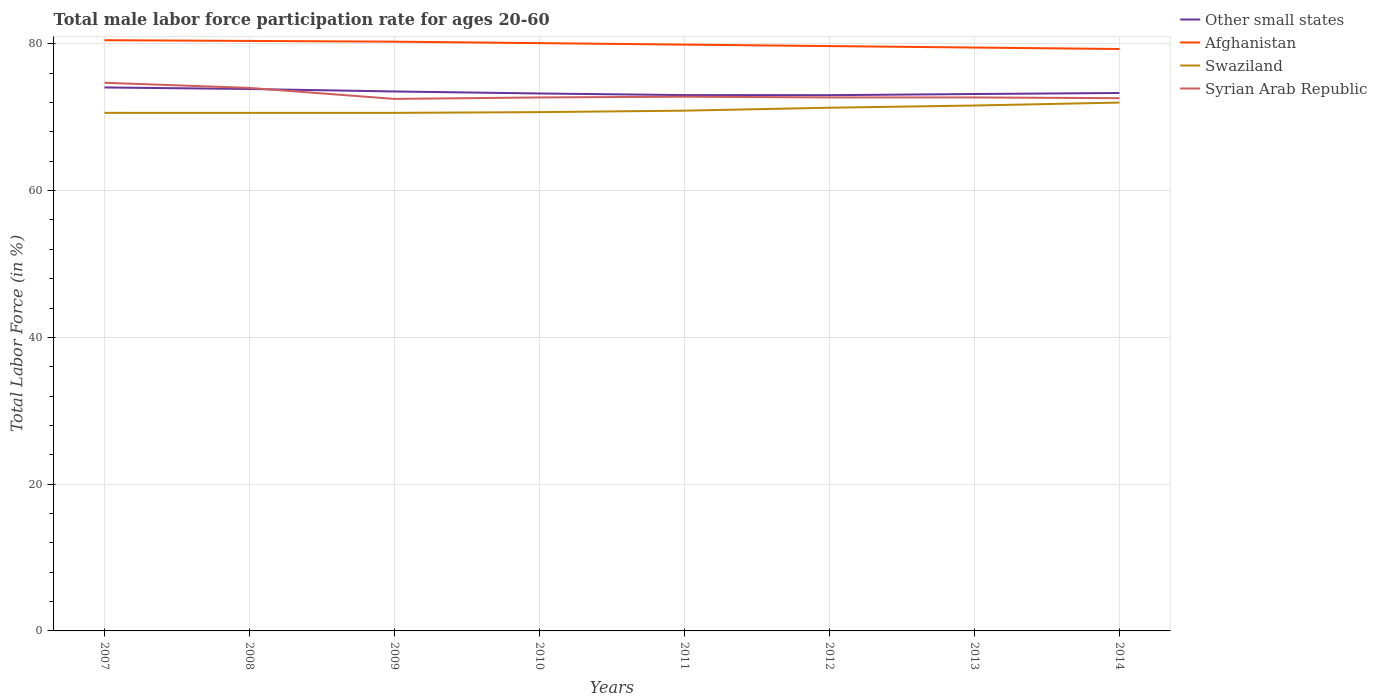How many different coloured lines are there?
Give a very brief answer. 4. Across all years, what is the maximum male labor force participation rate in Other small states?
Your answer should be very brief. 73.01. What is the total male labor force participation rate in Swaziland in the graph?
Offer a terse response. -0.3. What is the difference between the highest and the second highest male labor force participation rate in Swaziland?
Keep it short and to the point. 1.4. What is the difference between the highest and the lowest male labor force participation rate in Afghanistan?
Keep it short and to the point. 4. Is the male labor force participation rate in Other small states strictly greater than the male labor force participation rate in Afghanistan over the years?
Offer a terse response. Yes. How many lines are there?
Provide a succinct answer. 4. What is the difference between two consecutive major ticks on the Y-axis?
Your response must be concise. 20. Does the graph contain any zero values?
Keep it short and to the point. No. Does the graph contain grids?
Offer a terse response. Yes. Where does the legend appear in the graph?
Make the answer very short. Top right. How many legend labels are there?
Your answer should be very brief. 4. What is the title of the graph?
Your answer should be very brief. Total male labor force participation rate for ages 20-60. What is the label or title of the Y-axis?
Your response must be concise. Total Labor Force (in %). What is the Total Labor Force (in %) of Other small states in 2007?
Provide a succinct answer. 74.06. What is the Total Labor Force (in %) of Afghanistan in 2007?
Your answer should be compact. 80.5. What is the Total Labor Force (in %) in Swaziland in 2007?
Offer a terse response. 70.6. What is the Total Labor Force (in %) of Syrian Arab Republic in 2007?
Give a very brief answer. 74.7. What is the Total Labor Force (in %) in Other small states in 2008?
Your response must be concise. 73.85. What is the Total Labor Force (in %) in Afghanistan in 2008?
Offer a terse response. 80.4. What is the Total Labor Force (in %) of Swaziland in 2008?
Your answer should be compact. 70.6. What is the Total Labor Force (in %) in Syrian Arab Republic in 2008?
Your answer should be very brief. 74. What is the Total Labor Force (in %) in Other small states in 2009?
Give a very brief answer. 73.51. What is the Total Labor Force (in %) in Afghanistan in 2009?
Your answer should be compact. 80.3. What is the Total Labor Force (in %) of Swaziland in 2009?
Your answer should be compact. 70.6. What is the Total Labor Force (in %) in Syrian Arab Republic in 2009?
Provide a short and direct response. 72.5. What is the Total Labor Force (in %) in Other small states in 2010?
Your answer should be very brief. 73.24. What is the Total Labor Force (in %) of Afghanistan in 2010?
Provide a succinct answer. 80.1. What is the Total Labor Force (in %) of Swaziland in 2010?
Provide a short and direct response. 70.7. What is the Total Labor Force (in %) in Syrian Arab Republic in 2010?
Your answer should be very brief. 72.7. What is the Total Labor Force (in %) in Other small states in 2011?
Provide a short and direct response. 73.02. What is the Total Labor Force (in %) of Afghanistan in 2011?
Offer a terse response. 79.9. What is the Total Labor Force (in %) in Swaziland in 2011?
Keep it short and to the point. 70.9. What is the Total Labor Force (in %) in Syrian Arab Republic in 2011?
Provide a short and direct response. 72.8. What is the Total Labor Force (in %) of Other small states in 2012?
Ensure brevity in your answer.  73.01. What is the Total Labor Force (in %) in Afghanistan in 2012?
Keep it short and to the point. 79.7. What is the Total Labor Force (in %) of Swaziland in 2012?
Your response must be concise. 71.3. What is the Total Labor Force (in %) of Syrian Arab Republic in 2012?
Offer a terse response. 72.7. What is the Total Labor Force (in %) of Other small states in 2013?
Offer a terse response. 73.17. What is the Total Labor Force (in %) in Afghanistan in 2013?
Provide a succinct answer. 79.5. What is the Total Labor Force (in %) of Swaziland in 2013?
Provide a short and direct response. 71.6. What is the Total Labor Force (in %) in Syrian Arab Republic in 2013?
Your answer should be very brief. 72.7. What is the Total Labor Force (in %) of Other small states in 2014?
Your response must be concise. 73.31. What is the Total Labor Force (in %) in Afghanistan in 2014?
Ensure brevity in your answer.  79.3. What is the Total Labor Force (in %) of Swaziland in 2014?
Keep it short and to the point. 72. What is the Total Labor Force (in %) of Syrian Arab Republic in 2014?
Offer a very short reply. 72.6. Across all years, what is the maximum Total Labor Force (in %) in Other small states?
Keep it short and to the point. 74.06. Across all years, what is the maximum Total Labor Force (in %) in Afghanistan?
Provide a succinct answer. 80.5. Across all years, what is the maximum Total Labor Force (in %) in Swaziland?
Your answer should be compact. 72. Across all years, what is the maximum Total Labor Force (in %) of Syrian Arab Republic?
Ensure brevity in your answer.  74.7. Across all years, what is the minimum Total Labor Force (in %) in Other small states?
Offer a very short reply. 73.01. Across all years, what is the minimum Total Labor Force (in %) of Afghanistan?
Make the answer very short. 79.3. Across all years, what is the minimum Total Labor Force (in %) of Swaziland?
Your answer should be compact. 70.6. Across all years, what is the minimum Total Labor Force (in %) in Syrian Arab Republic?
Give a very brief answer. 72.5. What is the total Total Labor Force (in %) in Other small states in the graph?
Provide a short and direct response. 587.17. What is the total Total Labor Force (in %) in Afghanistan in the graph?
Your response must be concise. 639.7. What is the total Total Labor Force (in %) of Swaziland in the graph?
Provide a succinct answer. 568.3. What is the total Total Labor Force (in %) in Syrian Arab Republic in the graph?
Offer a very short reply. 584.7. What is the difference between the Total Labor Force (in %) in Other small states in 2007 and that in 2008?
Make the answer very short. 0.21. What is the difference between the Total Labor Force (in %) of Syrian Arab Republic in 2007 and that in 2008?
Your answer should be compact. 0.7. What is the difference between the Total Labor Force (in %) of Other small states in 2007 and that in 2009?
Your answer should be compact. 0.55. What is the difference between the Total Labor Force (in %) of Syrian Arab Republic in 2007 and that in 2009?
Offer a terse response. 2.2. What is the difference between the Total Labor Force (in %) of Other small states in 2007 and that in 2010?
Ensure brevity in your answer.  0.82. What is the difference between the Total Labor Force (in %) of Swaziland in 2007 and that in 2010?
Keep it short and to the point. -0.1. What is the difference between the Total Labor Force (in %) of Syrian Arab Republic in 2007 and that in 2010?
Offer a very short reply. 2. What is the difference between the Total Labor Force (in %) in Other small states in 2007 and that in 2011?
Your answer should be very brief. 1.04. What is the difference between the Total Labor Force (in %) in Swaziland in 2007 and that in 2011?
Your answer should be very brief. -0.3. What is the difference between the Total Labor Force (in %) in Other small states in 2007 and that in 2012?
Your answer should be very brief. 1.05. What is the difference between the Total Labor Force (in %) of Afghanistan in 2007 and that in 2012?
Provide a succinct answer. 0.8. What is the difference between the Total Labor Force (in %) of Other small states in 2007 and that in 2013?
Make the answer very short. 0.89. What is the difference between the Total Labor Force (in %) in Swaziland in 2007 and that in 2013?
Your response must be concise. -1. What is the difference between the Total Labor Force (in %) in Syrian Arab Republic in 2007 and that in 2013?
Offer a terse response. 2. What is the difference between the Total Labor Force (in %) in Other small states in 2007 and that in 2014?
Offer a very short reply. 0.75. What is the difference between the Total Labor Force (in %) in Afghanistan in 2007 and that in 2014?
Keep it short and to the point. 1.2. What is the difference between the Total Labor Force (in %) of Swaziland in 2007 and that in 2014?
Offer a very short reply. -1.4. What is the difference between the Total Labor Force (in %) of Syrian Arab Republic in 2007 and that in 2014?
Provide a short and direct response. 2.1. What is the difference between the Total Labor Force (in %) in Other small states in 2008 and that in 2009?
Keep it short and to the point. 0.34. What is the difference between the Total Labor Force (in %) of Afghanistan in 2008 and that in 2009?
Keep it short and to the point. 0.1. What is the difference between the Total Labor Force (in %) in Syrian Arab Republic in 2008 and that in 2009?
Offer a terse response. 1.5. What is the difference between the Total Labor Force (in %) of Other small states in 2008 and that in 2010?
Ensure brevity in your answer.  0.61. What is the difference between the Total Labor Force (in %) of Afghanistan in 2008 and that in 2010?
Provide a short and direct response. 0.3. What is the difference between the Total Labor Force (in %) in Swaziland in 2008 and that in 2010?
Offer a terse response. -0.1. What is the difference between the Total Labor Force (in %) in Syrian Arab Republic in 2008 and that in 2010?
Offer a terse response. 1.3. What is the difference between the Total Labor Force (in %) of Other small states in 2008 and that in 2011?
Offer a very short reply. 0.83. What is the difference between the Total Labor Force (in %) of Afghanistan in 2008 and that in 2011?
Your answer should be very brief. 0.5. What is the difference between the Total Labor Force (in %) in Other small states in 2008 and that in 2012?
Your response must be concise. 0.84. What is the difference between the Total Labor Force (in %) in Other small states in 2008 and that in 2013?
Make the answer very short. 0.68. What is the difference between the Total Labor Force (in %) in Afghanistan in 2008 and that in 2013?
Ensure brevity in your answer.  0.9. What is the difference between the Total Labor Force (in %) in Syrian Arab Republic in 2008 and that in 2013?
Your answer should be very brief. 1.3. What is the difference between the Total Labor Force (in %) in Other small states in 2008 and that in 2014?
Your answer should be compact. 0.54. What is the difference between the Total Labor Force (in %) of Syrian Arab Republic in 2008 and that in 2014?
Keep it short and to the point. 1.4. What is the difference between the Total Labor Force (in %) in Other small states in 2009 and that in 2010?
Provide a short and direct response. 0.28. What is the difference between the Total Labor Force (in %) in Swaziland in 2009 and that in 2010?
Your response must be concise. -0.1. What is the difference between the Total Labor Force (in %) in Other small states in 2009 and that in 2011?
Provide a short and direct response. 0.49. What is the difference between the Total Labor Force (in %) in Other small states in 2009 and that in 2012?
Your response must be concise. 0.5. What is the difference between the Total Labor Force (in %) of Afghanistan in 2009 and that in 2012?
Provide a short and direct response. 0.6. What is the difference between the Total Labor Force (in %) of Swaziland in 2009 and that in 2012?
Provide a short and direct response. -0.7. What is the difference between the Total Labor Force (in %) in Other small states in 2009 and that in 2013?
Provide a short and direct response. 0.35. What is the difference between the Total Labor Force (in %) of Afghanistan in 2009 and that in 2013?
Make the answer very short. 0.8. What is the difference between the Total Labor Force (in %) in Syrian Arab Republic in 2009 and that in 2013?
Provide a succinct answer. -0.2. What is the difference between the Total Labor Force (in %) of Other small states in 2009 and that in 2014?
Your answer should be very brief. 0.21. What is the difference between the Total Labor Force (in %) of Syrian Arab Republic in 2009 and that in 2014?
Ensure brevity in your answer.  -0.1. What is the difference between the Total Labor Force (in %) in Other small states in 2010 and that in 2011?
Your response must be concise. 0.22. What is the difference between the Total Labor Force (in %) of Afghanistan in 2010 and that in 2011?
Offer a terse response. 0.2. What is the difference between the Total Labor Force (in %) in Other small states in 2010 and that in 2012?
Give a very brief answer. 0.23. What is the difference between the Total Labor Force (in %) of Afghanistan in 2010 and that in 2012?
Ensure brevity in your answer.  0.4. What is the difference between the Total Labor Force (in %) in Swaziland in 2010 and that in 2012?
Provide a short and direct response. -0.6. What is the difference between the Total Labor Force (in %) of Other small states in 2010 and that in 2013?
Make the answer very short. 0.07. What is the difference between the Total Labor Force (in %) in Afghanistan in 2010 and that in 2013?
Offer a very short reply. 0.6. What is the difference between the Total Labor Force (in %) in Other small states in 2010 and that in 2014?
Keep it short and to the point. -0.07. What is the difference between the Total Labor Force (in %) of Syrian Arab Republic in 2010 and that in 2014?
Provide a short and direct response. 0.1. What is the difference between the Total Labor Force (in %) of Other small states in 2011 and that in 2012?
Give a very brief answer. 0.01. What is the difference between the Total Labor Force (in %) in Syrian Arab Republic in 2011 and that in 2012?
Offer a terse response. 0.1. What is the difference between the Total Labor Force (in %) in Other small states in 2011 and that in 2013?
Provide a succinct answer. -0.15. What is the difference between the Total Labor Force (in %) of Afghanistan in 2011 and that in 2013?
Keep it short and to the point. 0.4. What is the difference between the Total Labor Force (in %) of Other small states in 2011 and that in 2014?
Provide a succinct answer. -0.29. What is the difference between the Total Labor Force (in %) of Swaziland in 2011 and that in 2014?
Your answer should be compact. -1.1. What is the difference between the Total Labor Force (in %) of Syrian Arab Republic in 2011 and that in 2014?
Ensure brevity in your answer.  0.2. What is the difference between the Total Labor Force (in %) of Other small states in 2012 and that in 2013?
Your response must be concise. -0.16. What is the difference between the Total Labor Force (in %) of Syrian Arab Republic in 2012 and that in 2013?
Ensure brevity in your answer.  0. What is the difference between the Total Labor Force (in %) of Other small states in 2012 and that in 2014?
Keep it short and to the point. -0.3. What is the difference between the Total Labor Force (in %) in Afghanistan in 2012 and that in 2014?
Provide a succinct answer. 0.4. What is the difference between the Total Labor Force (in %) of Syrian Arab Republic in 2012 and that in 2014?
Your answer should be compact. 0.1. What is the difference between the Total Labor Force (in %) of Other small states in 2013 and that in 2014?
Provide a succinct answer. -0.14. What is the difference between the Total Labor Force (in %) of Afghanistan in 2013 and that in 2014?
Ensure brevity in your answer.  0.2. What is the difference between the Total Labor Force (in %) of Other small states in 2007 and the Total Labor Force (in %) of Afghanistan in 2008?
Your answer should be very brief. -6.34. What is the difference between the Total Labor Force (in %) in Other small states in 2007 and the Total Labor Force (in %) in Swaziland in 2008?
Provide a succinct answer. 3.46. What is the difference between the Total Labor Force (in %) of Other small states in 2007 and the Total Labor Force (in %) of Syrian Arab Republic in 2008?
Provide a short and direct response. 0.06. What is the difference between the Total Labor Force (in %) in Other small states in 2007 and the Total Labor Force (in %) in Afghanistan in 2009?
Give a very brief answer. -6.24. What is the difference between the Total Labor Force (in %) of Other small states in 2007 and the Total Labor Force (in %) of Swaziland in 2009?
Ensure brevity in your answer.  3.46. What is the difference between the Total Labor Force (in %) of Other small states in 2007 and the Total Labor Force (in %) of Syrian Arab Republic in 2009?
Ensure brevity in your answer.  1.56. What is the difference between the Total Labor Force (in %) in Other small states in 2007 and the Total Labor Force (in %) in Afghanistan in 2010?
Your answer should be compact. -6.04. What is the difference between the Total Labor Force (in %) in Other small states in 2007 and the Total Labor Force (in %) in Swaziland in 2010?
Provide a succinct answer. 3.36. What is the difference between the Total Labor Force (in %) in Other small states in 2007 and the Total Labor Force (in %) in Syrian Arab Republic in 2010?
Your answer should be very brief. 1.36. What is the difference between the Total Labor Force (in %) of Swaziland in 2007 and the Total Labor Force (in %) of Syrian Arab Republic in 2010?
Offer a very short reply. -2.1. What is the difference between the Total Labor Force (in %) of Other small states in 2007 and the Total Labor Force (in %) of Afghanistan in 2011?
Make the answer very short. -5.84. What is the difference between the Total Labor Force (in %) of Other small states in 2007 and the Total Labor Force (in %) of Swaziland in 2011?
Offer a terse response. 3.16. What is the difference between the Total Labor Force (in %) of Other small states in 2007 and the Total Labor Force (in %) of Syrian Arab Republic in 2011?
Provide a short and direct response. 1.26. What is the difference between the Total Labor Force (in %) of Other small states in 2007 and the Total Labor Force (in %) of Afghanistan in 2012?
Your answer should be compact. -5.64. What is the difference between the Total Labor Force (in %) in Other small states in 2007 and the Total Labor Force (in %) in Swaziland in 2012?
Your answer should be compact. 2.76. What is the difference between the Total Labor Force (in %) of Other small states in 2007 and the Total Labor Force (in %) of Syrian Arab Republic in 2012?
Provide a short and direct response. 1.36. What is the difference between the Total Labor Force (in %) in Afghanistan in 2007 and the Total Labor Force (in %) in Swaziland in 2012?
Give a very brief answer. 9.2. What is the difference between the Total Labor Force (in %) of Other small states in 2007 and the Total Labor Force (in %) of Afghanistan in 2013?
Offer a terse response. -5.44. What is the difference between the Total Labor Force (in %) in Other small states in 2007 and the Total Labor Force (in %) in Swaziland in 2013?
Ensure brevity in your answer.  2.46. What is the difference between the Total Labor Force (in %) of Other small states in 2007 and the Total Labor Force (in %) of Syrian Arab Republic in 2013?
Ensure brevity in your answer.  1.36. What is the difference between the Total Labor Force (in %) in Afghanistan in 2007 and the Total Labor Force (in %) in Swaziland in 2013?
Offer a very short reply. 8.9. What is the difference between the Total Labor Force (in %) in Afghanistan in 2007 and the Total Labor Force (in %) in Syrian Arab Republic in 2013?
Your answer should be very brief. 7.8. What is the difference between the Total Labor Force (in %) in Other small states in 2007 and the Total Labor Force (in %) in Afghanistan in 2014?
Keep it short and to the point. -5.24. What is the difference between the Total Labor Force (in %) in Other small states in 2007 and the Total Labor Force (in %) in Swaziland in 2014?
Provide a short and direct response. 2.06. What is the difference between the Total Labor Force (in %) of Other small states in 2007 and the Total Labor Force (in %) of Syrian Arab Republic in 2014?
Offer a very short reply. 1.46. What is the difference between the Total Labor Force (in %) of Swaziland in 2007 and the Total Labor Force (in %) of Syrian Arab Republic in 2014?
Keep it short and to the point. -2. What is the difference between the Total Labor Force (in %) of Other small states in 2008 and the Total Labor Force (in %) of Afghanistan in 2009?
Offer a terse response. -6.45. What is the difference between the Total Labor Force (in %) in Other small states in 2008 and the Total Labor Force (in %) in Swaziland in 2009?
Offer a very short reply. 3.25. What is the difference between the Total Labor Force (in %) of Other small states in 2008 and the Total Labor Force (in %) of Syrian Arab Republic in 2009?
Provide a short and direct response. 1.35. What is the difference between the Total Labor Force (in %) of Afghanistan in 2008 and the Total Labor Force (in %) of Syrian Arab Republic in 2009?
Give a very brief answer. 7.9. What is the difference between the Total Labor Force (in %) of Other small states in 2008 and the Total Labor Force (in %) of Afghanistan in 2010?
Provide a succinct answer. -6.25. What is the difference between the Total Labor Force (in %) of Other small states in 2008 and the Total Labor Force (in %) of Swaziland in 2010?
Provide a succinct answer. 3.15. What is the difference between the Total Labor Force (in %) in Other small states in 2008 and the Total Labor Force (in %) in Syrian Arab Republic in 2010?
Your response must be concise. 1.15. What is the difference between the Total Labor Force (in %) of Other small states in 2008 and the Total Labor Force (in %) of Afghanistan in 2011?
Give a very brief answer. -6.05. What is the difference between the Total Labor Force (in %) in Other small states in 2008 and the Total Labor Force (in %) in Swaziland in 2011?
Ensure brevity in your answer.  2.95. What is the difference between the Total Labor Force (in %) of Other small states in 2008 and the Total Labor Force (in %) of Syrian Arab Republic in 2011?
Provide a short and direct response. 1.05. What is the difference between the Total Labor Force (in %) in Other small states in 2008 and the Total Labor Force (in %) in Afghanistan in 2012?
Ensure brevity in your answer.  -5.85. What is the difference between the Total Labor Force (in %) in Other small states in 2008 and the Total Labor Force (in %) in Swaziland in 2012?
Give a very brief answer. 2.55. What is the difference between the Total Labor Force (in %) in Other small states in 2008 and the Total Labor Force (in %) in Syrian Arab Republic in 2012?
Offer a very short reply. 1.15. What is the difference between the Total Labor Force (in %) of Afghanistan in 2008 and the Total Labor Force (in %) of Syrian Arab Republic in 2012?
Keep it short and to the point. 7.7. What is the difference between the Total Labor Force (in %) of Swaziland in 2008 and the Total Labor Force (in %) of Syrian Arab Republic in 2012?
Offer a terse response. -2.1. What is the difference between the Total Labor Force (in %) of Other small states in 2008 and the Total Labor Force (in %) of Afghanistan in 2013?
Your response must be concise. -5.65. What is the difference between the Total Labor Force (in %) of Other small states in 2008 and the Total Labor Force (in %) of Swaziland in 2013?
Offer a terse response. 2.25. What is the difference between the Total Labor Force (in %) in Other small states in 2008 and the Total Labor Force (in %) in Syrian Arab Republic in 2013?
Ensure brevity in your answer.  1.15. What is the difference between the Total Labor Force (in %) of Afghanistan in 2008 and the Total Labor Force (in %) of Swaziland in 2013?
Ensure brevity in your answer.  8.8. What is the difference between the Total Labor Force (in %) in Swaziland in 2008 and the Total Labor Force (in %) in Syrian Arab Republic in 2013?
Keep it short and to the point. -2.1. What is the difference between the Total Labor Force (in %) of Other small states in 2008 and the Total Labor Force (in %) of Afghanistan in 2014?
Make the answer very short. -5.45. What is the difference between the Total Labor Force (in %) in Other small states in 2008 and the Total Labor Force (in %) in Swaziland in 2014?
Offer a very short reply. 1.85. What is the difference between the Total Labor Force (in %) of Other small states in 2008 and the Total Labor Force (in %) of Syrian Arab Republic in 2014?
Make the answer very short. 1.25. What is the difference between the Total Labor Force (in %) in Afghanistan in 2008 and the Total Labor Force (in %) in Syrian Arab Republic in 2014?
Provide a short and direct response. 7.8. What is the difference between the Total Labor Force (in %) of Swaziland in 2008 and the Total Labor Force (in %) of Syrian Arab Republic in 2014?
Offer a very short reply. -2. What is the difference between the Total Labor Force (in %) of Other small states in 2009 and the Total Labor Force (in %) of Afghanistan in 2010?
Make the answer very short. -6.59. What is the difference between the Total Labor Force (in %) in Other small states in 2009 and the Total Labor Force (in %) in Swaziland in 2010?
Give a very brief answer. 2.81. What is the difference between the Total Labor Force (in %) of Other small states in 2009 and the Total Labor Force (in %) of Syrian Arab Republic in 2010?
Ensure brevity in your answer.  0.81. What is the difference between the Total Labor Force (in %) in Afghanistan in 2009 and the Total Labor Force (in %) in Swaziland in 2010?
Ensure brevity in your answer.  9.6. What is the difference between the Total Labor Force (in %) in Afghanistan in 2009 and the Total Labor Force (in %) in Syrian Arab Republic in 2010?
Your response must be concise. 7.6. What is the difference between the Total Labor Force (in %) in Swaziland in 2009 and the Total Labor Force (in %) in Syrian Arab Republic in 2010?
Offer a very short reply. -2.1. What is the difference between the Total Labor Force (in %) in Other small states in 2009 and the Total Labor Force (in %) in Afghanistan in 2011?
Provide a succinct answer. -6.39. What is the difference between the Total Labor Force (in %) in Other small states in 2009 and the Total Labor Force (in %) in Swaziland in 2011?
Provide a short and direct response. 2.61. What is the difference between the Total Labor Force (in %) in Other small states in 2009 and the Total Labor Force (in %) in Syrian Arab Republic in 2011?
Your answer should be compact. 0.71. What is the difference between the Total Labor Force (in %) in Afghanistan in 2009 and the Total Labor Force (in %) in Swaziland in 2011?
Make the answer very short. 9.4. What is the difference between the Total Labor Force (in %) of Swaziland in 2009 and the Total Labor Force (in %) of Syrian Arab Republic in 2011?
Give a very brief answer. -2.2. What is the difference between the Total Labor Force (in %) in Other small states in 2009 and the Total Labor Force (in %) in Afghanistan in 2012?
Provide a short and direct response. -6.19. What is the difference between the Total Labor Force (in %) in Other small states in 2009 and the Total Labor Force (in %) in Swaziland in 2012?
Make the answer very short. 2.21. What is the difference between the Total Labor Force (in %) in Other small states in 2009 and the Total Labor Force (in %) in Syrian Arab Republic in 2012?
Ensure brevity in your answer.  0.81. What is the difference between the Total Labor Force (in %) of Afghanistan in 2009 and the Total Labor Force (in %) of Swaziland in 2012?
Offer a terse response. 9. What is the difference between the Total Labor Force (in %) of Afghanistan in 2009 and the Total Labor Force (in %) of Syrian Arab Republic in 2012?
Your answer should be compact. 7.6. What is the difference between the Total Labor Force (in %) in Swaziland in 2009 and the Total Labor Force (in %) in Syrian Arab Republic in 2012?
Provide a short and direct response. -2.1. What is the difference between the Total Labor Force (in %) of Other small states in 2009 and the Total Labor Force (in %) of Afghanistan in 2013?
Your answer should be very brief. -5.99. What is the difference between the Total Labor Force (in %) in Other small states in 2009 and the Total Labor Force (in %) in Swaziland in 2013?
Your answer should be very brief. 1.91. What is the difference between the Total Labor Force (in %) of Other small states in 2009 and the Total Labor Force (in %) of Syrian Arab Republic in 2013?
Make the answer very short. 0.81. What is the difference between the Total Labor Force (in %) of Swaziland in 2009 and the Total Labor Force (in %) of Syrian Arab Republic in 2013?
Offer a terse response. -2.1. What is the difference between the Total Labor Force (in %) in Other small states in 2009 and the Total Labor Force (in %) in Afghanistan in 2014?
Your response must be concise. -5.79. What is the difference between the Total Labor Force (in %) in Other small states in 2009 and the Total Labor Force (in %) in Swaziland in 2014?
Give a very brief answer. 1.51. What is the difference between the Total Labor Force (in %) in Other small states in 2009 and the Total Labor Force (in %) in Syrian Arab Republic in 2014?
Make the answer very short. 0.91. What is the difference between the Total Labor Force (in %) in Afghanistan in 2009 and the Total Labor Force (in %) in Swaziland in 2014?
Provide a succinct answer. 8.3. What is the difference between the Total Labor Force (in %) of Afghanistan in 2009 and the Total Labor Force (in %) of Syrian Arab Republic in 2014?
Your answer should be compact. 7.7. What is the difference between the Total Labor Force (in %) of Swaziland in 2009 and the Total Labor Force (in %) of Syrian Arab Republic in 2014?
Keep it short and to the point. -2. What is the difference between the Total Labor Force (in %) of Other small states in 2010 and the Total Labor Force (in %) of Afghanistan in 2011?
Keep it short and to the point. -6.66. What is the difference between the Total Labor Force (in %) of Other small states in 2010 and the Total Labor Force (in %) of Swaziland in 2011?
Keep it short and to the point. 2.34. What is the difference between the Total Labor Force (in %) of Other small states in 2010 and the Total Labor Force (in %) of Syrian Arab Republic in 2011?
Your answer should be very brief. 0.44. What is the difference between the Total Labor Force (in %) of Other small states in 2010 and the Total Labor Force (in %) of Afghanistan in 2012?
Your response must be concise. -6.46. What is the difference between the Total Labor Force (in %) of Other small states in 2010 and the Total Labor Force (in %) of Swaziland in 2012?
Give a very brief answer. 1.94. What is the difference between the Total Labor Force (in %) of Other small states in 2010 and the Total Labor Force (in %) of Syrian Arab Republic in 2012?
Make the answer very short. 0.54. What is the difference between the Total Labor Force (in %) in Afghanistan in 2010 and the Total Labor Force (in %) in Syrian Arab Republic in 2012?
Provide a succinct answer. 7.4. What is the difference between the Total Labor Force (in %) in Other small states in 2010 and the Total Labor Force (in %) in Afghanistan in 2013?
Offer a terse response. -6.26. What is the difference between the Total Labor Force (in %) of Other small states in 2010 and the Total Labor Force (in %) of Swaziland in 2013?
Make the answer very short. 1.64. What is the difference between the Total Labor Force (in %) in Other small states in 2010 and the Total Labor Force (in %) in Syrian Arab Republic in 2013?
Make the answer very short. 0.54. What is the difference between the Total Labor Force (in %) of Afghanistan in 2010 and the Total Labor Force (in %) of Syrian Arab Republic in 2013?
Give a very brief answer. 7.4. What is the difference between the Total Labor Force (in %) in Swaziland in 2010 and the Total Labor Force (in %) in Syrian Arab Republic in 2013?
Offer a very short reply. -2. What is the difference between the Total Labor Force (in %) in Other small states in 2010 and the Total Labor Force (in %) in Afghanistan in 2014?
Give a very brief answer. -6.06. What is the difference between the Total Labor Force (in %) of Other small states in 2010 and the Total Labor Force (in %) of Swaziland in 2014?
Provide a short and direct response. 1.24. What is the difference between the Total Labor Force (in %) in Other small states in 2010 and the Total Labor Force (in %) in Syrian Arab Republic in 2014?
Provide a short and direct response. 0.64. What is the difference between the Total Labor Force (in %) of Afghanistan in 2010 and the Total Labor Force (in %) of Swaziland in 2014?
Keep it short and to the point. 8.1. What is the difference between the Total Labor Force (in %) in Afghanistan in 2010 and the Total Labor Force (in %) in Syrian Arab Republic in 2014?
Provide a short and direct response. 7.5. What is the difference between the Total Labor Force (in %) in Other small states in 2011 and the Total Labor Force (in %) in Afghanistan in 2012?
Offer a very short reply. -6.68. What is the difference between the Total Labor Force (in %) of Other small states in 2011 and the Total Labor Force (in %) of Swaziland in 2012?
Ensure brevity in your answer.  1.72. What is the difference between the Total Labor Force (in %) of Other small states in 2011 and the Total Labor Force (in %) of Syrian Arab Republic in 2012?
Make the answer very short. 0.32. What is the difference between the Total Labor Force (in %) in Afghanistan in 2011 and the Total Labor Force (in %) in Swaziland in 2012?
Your answer should be compact. 8.6. What is the difference between the Total Labor Force (in %) of Afghanistan in 2011 and the Total Labor Force (in %) of Syrian Arab Republic in 2012?
Your answer should be compact. 7.2. What is the difference between the Total Labor Force (in %) of Other small states in 2011 and the Total Labor Force (in %) of Afghanistan in 2013?
Offer a very short reply. -6.48. What is the difference between the Total Labor Force (in %) in Other small states in 2011 and the Total Labor Force (in %) in Swaziland in 2013?
Keep it short and to the point. 1.42. What is the difference between the Total Labor Force (in %) of Other small states in 2011 and the Total Labor Force (in %) of Syrian Arab Republic in 2013?
Offer a terse response. 0.32. What is the difference between the Total Labor Force (in %) in Afghanistan in 2011 and the Total Labor Force (in %) in Syrian Arab Republic in 2013?
Your response must be concise. 7.2. What is the difference between the Total Labor Force (in %) in Swaziland in 2011 and the Total Labor Force (in %) in Syrian Arab Republic in 2013?
Keep it short and to the point. -1.8. What is the difference between the Total Labor Force (in %) in Other small states in 2011 and the Total Labor Force (in %) in Afghanistan in 2014?
Provide a succinct answer. -6.28. What is the difference between the Total Labor Force (in %) in Other small states in 2011 and the Total Labor Force (in %) in Swaziland in 2014?
Your answer should be compact. 1.02. What is the difference between the Total Labor Force (in %) of Other small states in 2011 and the Total Labor Force (in %) of Syrian Arab Republic in 2014?
Keep it short and to the point. 0.42. What is the difference between the Total Labor Force (in %) in Swaziland in 2011 and the Total Labor Force (in %) in Syrian Arab Republic in 2014?
Keep it short and to the point. -1.7. What is the difference between the Total Labor Force (in %) of Other small states in 2012 and the Total Labor Force (in %) of Afghanistan in 2013?
Keep it short and to the point. -6.49. What is the difference between the Total Labor Force (in %) of Other small states in 2012 and the Total Labor Force (in %) of Swaziland in 2013?
Provide a succinct answer. 1.41. What is the difference between the Total Labor Force (in %) in Other small states in 2012 and the Total Labor Force (in %) in Syrian Arab Republic in 2013?
Ensure brevity in your answer.  0.31. What is the difference between the Total Labor Force (in %) of Afghanistan in 2012 and the Total Labor Force (in %) of Syrian Arab Republic in 2013?
Ensure brevity in your answer.  7. What is the difference between the Total Labor Force (in %) in Swaziland in 2012 and the Total Labor Force (in %) in Syrian Arab Republic in 2013?
Offer a very short reply. -1.4. What is the difference between the Total Labor Force (in %) of Other small states in 2012 and the Total Labor Force (in %) of Afghanistan in 2014?
Offer a very short reply. -6.29. What is the difference between the Total Labor Force (in %) of Other small states in 2012 and the Total Labor Force (in %) of Swaziland in 2014?
Your answer should be compact. 1.01. What is the difference between the Total Labor Force (in %) of Other small states in 2012 and the Total Labor Force (in %) of Syrian Arab Republic in 2014?
Make the answer very short. 0.41. What is the difference between the Total Labor Force (in %) of Afghanistan in 2012 and the Total Labor Force (in %) of Syrian Arab Republic in 2014?
Offer a very short reply. 7.1. What is the difference between the Total Labor Force (in %) in Other small states in 2013 and the Total Labor Force (in %) in Afghanistan in 2014?
Provide a short and direct response. -6.13. What is the difference between the Total Labor Force (in %) in Other small states in 2013 and the Total Labor Force (in %) in Swaziland in 2014?
Provide a short and direct response. 1.17. What is the difference between the Total Labor Force (in %) in Other small states in 2013 and the Total Labor Force (in %) in Syrian Arab Republic in 2014?
Ensure brevity in your answer.  0.57. What is the difference between the Total Labor Force (in %) of Afghanistan in 2013 and the Total Labor Force (in %) of Swaziland in 2014?
Your answer should be very brief. 7.5. What is the difference between the Total Labor Force (in %) in Afghanistan in 2013 and the Total Labor Force (in %) in Syrian Arab Republic in 2014?
Provide a succinct answer. 6.9. What is the difference between the Total Labor Force (in %) of Swaziland in 2013 and the Total Labor Force (in %) of Syrian Arab Republic in 2014?
Your answer should be very brief. -1. What is the average Total Labor Force (in %) in Other small states per year?
Ensure brevity in your answer.  73.4. What is the average Total Labor Force (in %) of Afghanistan per year?
Keep it short and to the point. 79.96. What is the average Total Labor Force (in %) of Swaziland per year?
Your answer should be very brief. 71.04. What is the average Total Labor Force (in %) in Syrian Arab Republic per year?
Offer a very short reply. 73.09. In the year 2007, what is the difference between the Total Labor Force (in %) of Other small states and Total Labor Force (in %) of Afghanistan?
Give a very brief answer. -6.44. In the year 2007, what is the difference between the Total Labor Force (in %) in Other small states and Total Labor Force (in %) in Swaziland?
Ensure brevity in your answer.  3.46. In the year 2007, what is the difference between the Total Labor Force (in %) of Other small states and Total Labor Force (in %) of Syrian Arab Republic?
Provide a short and direct response. -0.64. In the year 2007, what is the difference between the Total Labor Force (in %) in Afghanistan and Total Labor Force (in %) in Swaziland?
Give a very brief answer. 9.9. In the year 2007, what is the difference between the Total Labor Force (in %) in Afghanistan and Total Labor Force (in %) in Syrian Arab Republic?
Offer a very short reply. 5.8. In the year 2008, what is the difference between the Total Labor Force (in %) in Other small states and Total Labor Force (in %) in Afghanistan?
Your answer should be compact. -6.55. In the year 2008, what is the difference between the Total Labor Force (in %) of Other small states and Total Labor Force (in %) of Swaziland?
Offer a terse response. 3.25. In the year 2008, what is the difference between the Total Labor Force (in %) of Other small states and Total Labor Force (in %) of Syrian Arab Republic?
Offer a terse response. -0.15. In the year 2009, what is the difference between the Total Labor Force (in %) in Other small states and Total Labor Force (in %) in Afghanistan?
Make the answer very short. -6.79. In the year 2009, what is the difference between the Total Labor Force (in %) of Other small states and Total Labor Force (in %) of Swaziland?
Provide a short and direct response. 2.91. In the year 2009, what is the difference between the Total Labor Force (in %) in Other small states and Total Labor Force (in %) in Syrian Arab Republic?
Keep it short and to the point. 1.01. In the year 2009, what is the difference between the Total Labor Force (in %) in Afghanistan and Total Labor Force (in %) in Swaziland?
Give a very brief answer. 9.7. In the year 2009, what is the difference between the Total Labor Force (in %) of Afghanistan and Total Labor Force (in %) of Syrian Arab Republic?
Offer a very short reply. 7.8. In the year 2010, what is the difference between the Total Labor Force (in %) of Other small states and Total Labor Force (in %) of Afghanistan?
Offer a terse response. -6.86. In the year 2010, what is the difference between the Total Labor Force (in %) of Other small states and Total Labor Force (in %) of Swaziland?
Offer a terse response. 2.54. In the year 2010, what is the difference between the Total Labor Force (in %) of Other small states and Total Labor Force (in %) of Syrian Arab Republic?
Your response must be concise. 0.54. In the year 2010, what is the difference between the Total Labor Force (in %) in Afghanistan and Total Labor Force (in %) in Syrian Arab Republic?
Your response must be concise. 7.4. In the year 2010, what is the difference between the Total Labor Force (in %) in Swaziland and Total Labor Force (in %) in Syrian Arab Republic?
Ensure brevity in your answer.  -2. In the year 2011, what is the difference between the Total Labor Force (in %) of Other small states and Total Labor Force (in %) of Afghanistan?
Offer a terse response. -6.88. In the year 2011, what is the difference between the Total Labor Force (in %) of Other small states and Total Labor Force (in %) of Swaziland?
Your response must be concise. 2.12. In the year 2011, what is the difference between the Total Labor Force (in %) of Other small states and Total Labor Force (in %) of Syrian Arab Republic?
Provide a succinct answer. 0.22. In the year 2011, what is the difference between the Total Labor Force (in %) in Afghanistan and Total Labor Force (in %) in Syrian Arab Republic?
Your response must be concise. 7.1. In the year 2012, what is the difference between the Total Labor Force (in %) of Other small states and Total Labor Force (in %) of Afghanistan?
Ensure brevity in your answer.  -6.69. In the year 2012, what is the difference between the Total Labor Force (in %) in Other small states and Total Labor Force (in %) in Swaziland?
Provide a short and direct response. 1.71. In the year 2012, what is the difference between the Total Labor Force (in %) in Other small states and Total Labor Force (in %) in Syrian Arab Republic?
Keep it short and to the point. 0.31. In the year 2012, what is the difference between the Total Labor Force (in %) of Afghanistan and Total Labor Force (in %) of Syrian Arab Republic?
Your response must be concise. 7. In the year 2012, what is the difference between the Total Labor Force (in %) of Swaziland and Total Labor Force (in %) of Syrian Arab Republic?
Your answer should be compact. -1.4. In the year 2013, what is the difference between the Total Labor Force (in %) of Other small states and Total Labor Force (in %) of Afghanistan?
Provide a succinct answer. -6.33. In the year 2013, what is the difference between the Total Labor Force (in %) of Other small states and Total Labor Force (in %) of Swaziland?
Give a very brief answer. 1.57. In the year 2013, what is the difference between the Total Labor Force (in %) in Other small states and Total Labor Force (in %) in Syrian Arab Republic?
Offer a terse response. 0.47. In the year 2013, what is the difference between the Total Labor Force (in %) in Afghanistan and Total Labor Force (in %) in Swaziland?
Ensure brevity in your answer.  7.9. In the year 2013, what is the difference between the Total Labor Force (in %) of Swaziland and Total Labor Force (in %) of Syrian Arab Republic?
Offer a very short reply. -1.1. In the year 2014, what is the difference between the Total Labor Force (in %) of Other small states and Total Labor Force (in %) of Afghanistan?
Ensure brevity in your answer.  -5.99. In the year 2014, what is the difference between the Total Labor Force (in %) of Other small states and Total Labor Force (in %) of Swaziland?
Make the answer very short. 1.31. In the year 2014, what is the difference between the Total Labor Force (in %) in Other small states and Total Labor Force (in %) in Syrian Arab Republic?
Offer a terse response. 0.71. What is the ratio of the Total Labor Force (in %) of Afghanistan in 2007 to that in 2008?
Provide a short and direct response. 1. What is the ratio of the Total Labor Force (in %) in Syrian Arab Republic in 2007 to that in 2008?
Offer a very short reply. 1.01. What is the ratio of the Total Labor Force (in %) in Other small states in 2007 to that in 2009?
Provide a succinct answer. 1.01. What is the ratio of the Total Labor Force (in %) of Syrian Arab Republic in 2007 to that in 2009?
Keep it short and to the point. 1.03. What is the ratio of the Total Labor Force (in %) in Other small states in 2007 to that in 2010?
Give a very brief answer. 1.01. What is the ratio of the Total Labor Force (in %) of Swaziland in 2007 to that in 2010?
Your answer should be very brief. 1. What is the ratio of the Total Labor Force (in %) in Syrian Arab Republic in 2007 to that in 2010?
Offer a very short reply. 1.03. What is the ratio of the Total Labor Force (in %) of Other small states in 2007 to that in 2011?
Give a very brief answer. 1.01. What is the ratio of the Total Labor Force (in %) in Afghanistan in 2007 to that in 2011?
Your answer should be very brief. 1.01. What is the ratio of the Total Labor Force (in %) of Syrian Arab Republic in 2007 to that in 2011?
Offer a terse response. 1.03. What is the ratio of the Total Labor Force (in %) in Other small states in 2007 to that in 2012?
Offer a very short reply. 1.01. What is the ratio of the Total Labor Force (in %) of Swaziland in 2007 to that in 2012?
Your response must be concise. 0.99. What is the ratio of the Total Labor Force (in %) in Syrian Arab Republic in 2007 to that in 2012?
Give a very brief answer. 1.03. What is the ratio of the Total Labor Force (in %) of Other small states in 2007 to that in 2013?
Ensure brevity in your answer.  1.01. What is the ratio of the Total Labor Force (in %) in Afghanistan in 2007 to that in 2013?
Your response must be concise. 1.01. What is the ratio of the Total Labor Force (in %) in Syrian Arab Republic in 2007 to that in 2013?
Make the answer very short. 1.03. What is the ratio of the Total Labor Force (in %) of Other small states in 2007 to that in 2014?
Make the answer very short. 1.01. What is the ratio of the Total Labor Force (in %) in Afghanistan in 2007 to that in 2014?
Provide a short and direct response. 1.02. What is the ratio of the Total Labor Force (in %) in Swaziland in 2007 to that in 2014?
Give a very brief answer. 0.98. What is the ratio of the Total Labor Force (in %) in Syrian Arab Republic in 2007 to that in 2014?
Provide a short and direct response. 1.03. What is the ratio of the Total Labor Force (in %) in Afghanistan in 2008 to that in 2009?
Offer a very short reply. 1. What is the ratio of the Total Labor Force (in %) in Syrian Arab Republic in 2008 to that in 2009?
Provide a short and direct response. 1.02. What is the ratio of the Total Labor Force (in %) of Other small states in 2008 to that in 2010?
Keep it short and to the point. 1.01. What is the ratio of the Total Labor Force (in %) of Swaziland in 2008 to that in 2010?
Your response must be concise. 1. What is the ratio of the Total Labor Force (in %) in Syrian Arab Republic in 2008 to that in 2010?
Your response must be concise. 1.02. What is the ratio of the Total Labor Force (in %) in Other small states in 2008 to that in 2011?
Offer a very short reply. 1.01. What is the ratio of the Total Labor Force (in %) of Swaziland in 2008 to that in 2011?
Offer a very short reply. 1. What is the ratio of the Total Labor Force (in %) in Syrian Arab Republic in 2008 to that in 2011?
Keep it short and to the point. 1.02. What is the ratio of the Total Labor Force (in %) of Other small states in 2008 to that in 2012?
Give a very brief answer. 1.01. What is the ratio of the Total Labor Force (in %) of Afghanistan in 2008 to that in 2012?
Make the answer very short. 1.01. What is the ratio of the Total Labor Force (in %) of Swaziland in 2008 to that in 2012?
Provide a short and direct response. 0.99. What is the ratio of the Total Labor Force (in %) in Syrian Arab Republic in 2008 to that in 2012?
Ensure brevity in your answer.  1.02. What is the ratio of the Total Labor Force (in %) in Other small states in 2008 to that in 2013?
Offer a terse response. 1.01. What is the ratio of the Total Labor Force (in %) of Afghanistan in 2008 to that in 2013?
Provide a succinct answer. 1.01. What is the ratio of the Total Labor Force (in %) in Syrian Arab Republic in 2008 to that in 2013?
Your answer should be compact. 1.02. What is the ratio of the Total Labor Force (in %) of Other small states in 2008 to that in 2014?
Ensure brevity in your answer.  1.01. What is the ratio of the Total Labor Force (in %) in Afghanistan in 2008 to that in 2014?
Your answer should be compact. 1.01. What is the ratio of the Total Labor Force (in %) in Swaziland in 2008 to that in 2014?
Give a very brief answer. 0.98. What is the ratio of the Total Labor Force (in %) in Syrian Arab Republic in 2008 to that in 2014?
Offer a terse response. 1.02. What is the ratio of the Total Labor Force (in %) of Other small states in 2009 to that in 2010?
Your response must be concise. 1. What is the ratio of the Total Labor Force (in %) in Afghanistan in 2009 to that in 2010?
Offer a very short reply. 1. What is the ratio of the Total Labor Force (in %) of Other small states in 2009 to that in 2011?
Provide a short and direct response. 1.01. What is the ratio of the Total Labor Force (in %) in Swaziland in 2009 to that in 2011?
Your answer should be compact. 1. What is the ratio of the Total Labor Force (in %) of Syrian Arab Republic in 2009 to that in 2011?
Provide a succinct answer. 1. What is the ratio of the Total Labor Force (in %) of Other small states in 2009 to that in 2012?
Your answer should be very brief. 1.01. What is the ratio of the Total Labor Force (in %) in Afghanistan in 2009 to that in 2012?
Offer a terse response. 1.01. What is the ratio of the Total Labor Force (in %) in Swaziland in 2009 to that in 2012?
Your answer should be compact. 0.99. What is the ratio of the Total Labor Force (in %) of Syrian Arab Republic in 2009 to that in 2012?
Provide a succinct answer. 1. What is the ratio of the Total Labor Force (in %) in Other small states in 2009 to that in 2013?
Your answer should be compact. 1. What is the ratio of the Total Labor Force (in %) of Afghanistan in 2009 to that in 2013?
Your response must be concise. 1.01. What is the ratio of the Total Labor Force (in %) of Syrian Arab Republic in 2009 to that in 2013?
Your response must be concise. 1. What is the ratio of the Total Labor Force (in %) of Other small states in 2009 to that in 2014?
Give a very brief answer. 1. What is the ratio of the Total Labor Force (in %) of Afghanistan in 2009 to that in 2014?
Your answer should be very brief. 1.01. What is the ratio of the Total Labor Force (in %) in Swaziland in 2009 to that in 2014?
Ensure brevity in your answer.  0.98. What is the ratio of the Total Labor Force (in %) of Syrian Arab Republic in 2009 to that in 2014?
Give a very brief answer. 1. What is the ratio of the Total Labor Force (in %) in Other small states in 2010 to that in 2011?
Make the answer very short. 1. What is the ratio of the Total Labor Force (in %) in Afghanistan in 2010 to that in 2011?
Ensure brevity in your answer.  1. What is the ratio of the Total Labor Force (in %) in Swaziland in 2010 to that in 2011?
Provide a short and direct response. 1. What is the ratio of the Total Labor Force (in %) of Syrian Arab Republic in 2010 to that in 2011?
Offer a very short reply. 1. What is the ratio of the Total Labor Force (in %) in Swaziland in 2010 to that in 2012?
Offer a terse response. 0.99. What is the ratio of the Total Labor Force (in %) of Other small states in 2010 to that in 2013?
Provide a succinct answer. 1. What is the ratio of the Total Labor Force (in %) of Afghanistan in 2010 to that in 2013?
Provide a short and direct response. 1.01. What is the ratio of the Total Labor Force (in %) of Swaziland in 2010 to that in 2013?
Provide a succinct answer. 0.99. What is the ratio of the Total Labor Force (in %) in Syrian Arab Republic in 2010 to that in 2013?
Ensure brevity in your answer.  1. What is the ratio of the Total Labor Force (in %) of Swaziland in 2010 to that in 2014?
Make the answer very short. 0.98. What is the ratio of the Total Labor Force (in %) in Syrian Arab Republic in 2010 to that in 2014?
Ensure brevity in your answer.  1. What is the ratio of the Total Labor Force (in %) of Syrian Arab Republic in 2011 to that in 2012?
Ensure brevity in your answer.  1. What is the ratio of the Total Labor Force (in %) of Swaziland in 2011 to that in 2013?
Your answer should be very brief. 0.99. What is the ratio of the Total Labor Force (in %) of Other small states in 2011 to that in 2014?
Provide a succinct answer. 1. What is the ratio of the Total Labor Force (in %) in Afghanistan in 2011 to that in 2014?
Offer a very short reply. 1.01. What is the ratio of the Total Labor Force (in %) in Swaziland in 2011 to that in 2014?
Ensure brevity in your answer.  0.98. What is the ratio of the Total Labor Force (in %) of Syrian Arab Republic in 2011 to that in 2014?
Your answer should be very brief. 1. What is the ratio of the Total Labor Force (in %) in Other small states in 2012 to that in 2013?
Keep it short and to the point. 1. What is the ratio of the Total Labor Force (in %) of Afghanistan in 2012 to that in 2013?
Offer a terse response. 1. What is the ratio of the Total Labor Force (in %) in Swaziland in 2012 to that in 2013?
Give a very brief answer. 1. What is the ratio of the Total Labor Force (in %) in Other small states in 2012 to that in 2014?
Your response must be concise. 1. What is the ratio of the Total Labor Force (in %) of Afghanistan in 2012 to that in 2014?
Ensure brevity in your answer.  1. What is the ratio of the Total Labor Force (in %) of Swaziland in 2012 to that in 2014?
Provide a short and direct response. 0.99. What is the ratio of the Total Labor Force (in %) of Other small states in 2013 to that in 2014?
Ensure brevity in your answer.  1. What is the ratio of the Total Labor Force (in %) in Afghanistan in 2013 to that in 2014?
Make the answer very short. 1. What is the ratio of the Total Labor Force (in %) of Swaziland in 2013 to that in 2014?
Provide a succinct answer. 0.99. What is the ratio of the Total Labor Force (in %) in Syrian Arab Republic in 2013 to that in 2014?
Give a very brief answer. 1. What is the difference between the highest and the second highest Total Labor Force (in %) of Other small states?
Provide a succinct answer. 0.21. What is the difference between the highest and the second highest Total Labor Force (in %) in Afghanistan?
Provide a succinct answer. 0.1. What is the difference between the highest and the lowest Total Labor Force (in %) of Other small states?
Your response must be concise. 1.05. What is the difference between the highest and the lowest Total Labor Force (in %) in Afghanistan?
Offer a terse response. 1.2. 